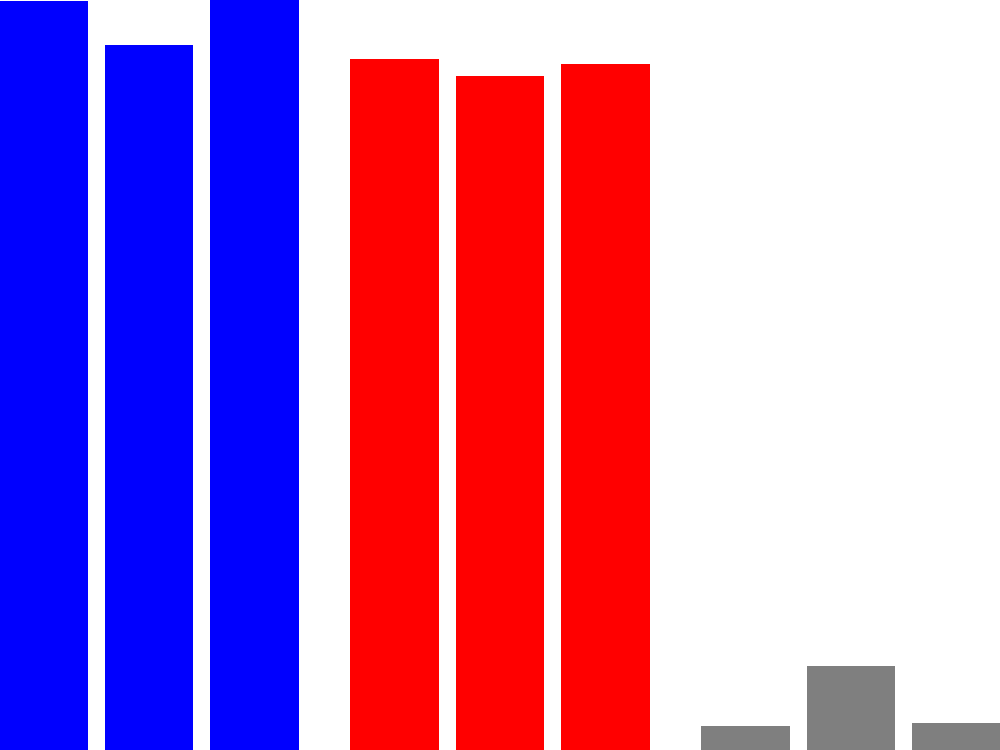Based on the historical voting patterns shown in the bar graph, which party is most likely to win the next election, and what strategy would you recommend to secure victory? To answer this question, we need to analyze the trends in the voting patterns:

1. Democratic Party (Blue):
   - 2012: 51.2%
   - 2016: 48.2% (decrease)
   - 2020: 51.3% (increase)

2. Republican Party (Red):
   - 2012: 47.2%
   - 2016: 46.1% (slight decrease)
   - 2020: 46.9% (slight increase)

3. Other Parties (Gray):
   - 2012: 1.6%
   - 2016: 5.7% (significant increase)
   - 2020: 1.8% (back to normal)

Analysis:
1. The Democratic Party has shown resilience, bouncing back from a loss in 2016 to win in 2020.
2. The Republican Party has maintained a relatively stable voter base, with minor fluctuations.
3. The spike in "Other" votes in 2016 suggests potential voter dissatisfaction with major parties.

Based on this data, the Democratic Party appears to have a slight edge, but the margin is narrow.

Strategy recommendation:
1. Focus on maintaining the current voter base by emphasizing successful policies.
2. Target swing voters who may have voted for "Other" parties in 2016.
3. Address key issues that led to the 2016 loss to prevent a repeat scenario.
4. Implement a strong get-out-the-vote campaign to maximize turnout among supporters.
5. Develop a narrative that highlights the party's ability to govern effectively and deliver results.
Answer: Democratic Party likely to win; focus on base retention, swing voters, and addressing 2016 loss factors. 